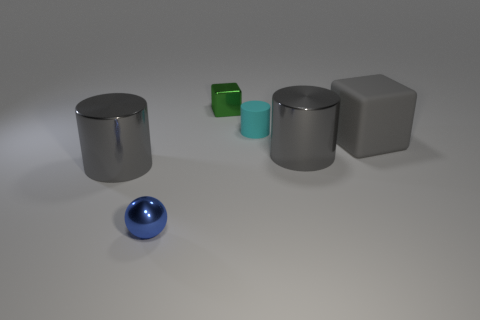There is a large shiny thing that is left of the tiny metal object that is in front of the cube right of the tiny green block; what is its color?
Offer a very short reply. Gray. What material is the large gray object that is the same shape as the small green thing?
Ensure brevity in your answer.  Rubber. There is a cyan rubber cylinder that is left of the large gray cylinder on the right side of the tiny sphere; how big is it?
Provide a short and direct response. Small. There is a big object that is left of the small blue metallic object; what is it made of?
Your answer should be compact. Metal. The gray block that is made of the same material as the tiny cylinder is what size?
Keep it short and to the point. Large. What number of green metallic objects have the same shape as the blue object?
Your answer should be very brief. 0. There is a green shiny object; is its shape the same as the large gray metal thing to the right of the rubber cylinder?
Your response must be concise. No. Is there another small blue object made of the same material as the tiny blue thing?
Provide a short and direct response. No. The thing on the right side of the metal thing that is on the right side of the green metallic object is made of what material?
Give a very brief answer. Rubber. What is the size of the gray cylinder right of the small green thing right of the tiny metallic object that is in front of the big gray matte cube?
Your response must be concise. Large. 